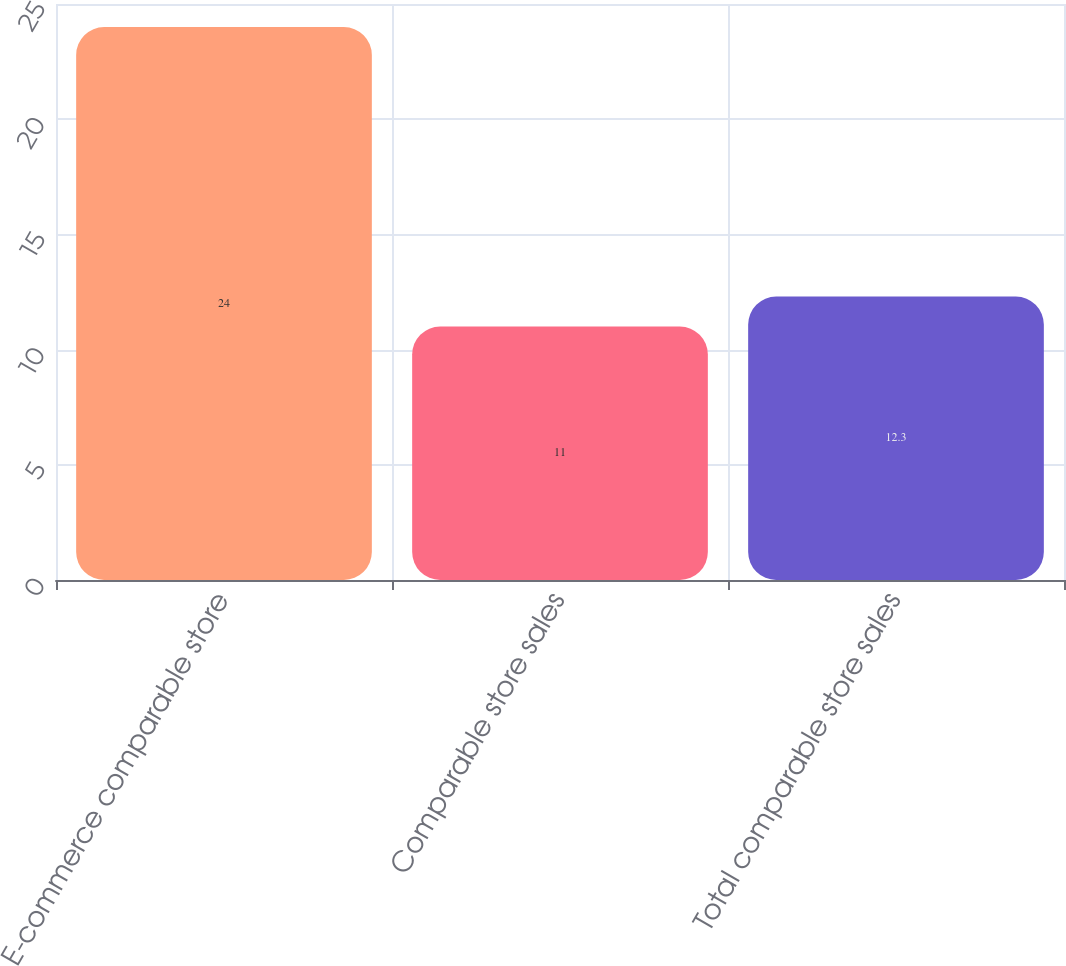Convert chart to OTSL. <chart><loc_0><loc_0><loc_500><loc_500><bar_chart><fcel>E-commerce comparable store<fcel>Comparable store sales<fcel>Total comparable store sales<nl><fcel>24<fcel>11<fcel>12.3<nl></chart> 